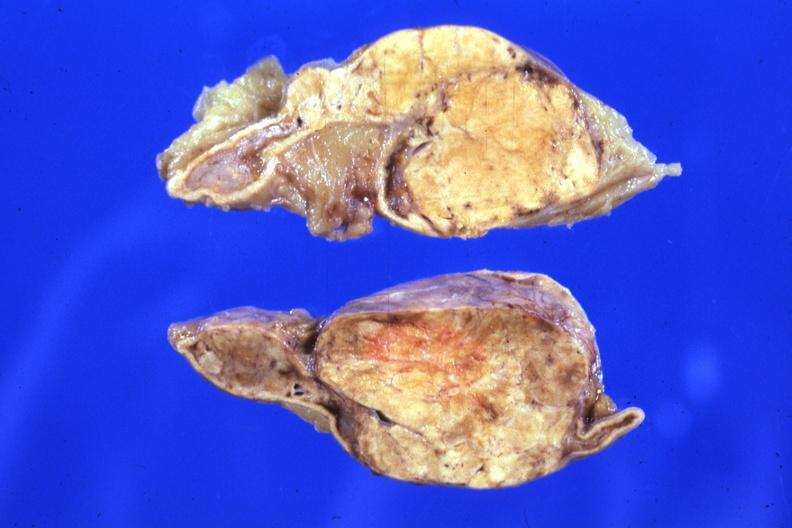where does this belong to?
Answer the question using a single word or phrase. Endocrine system 